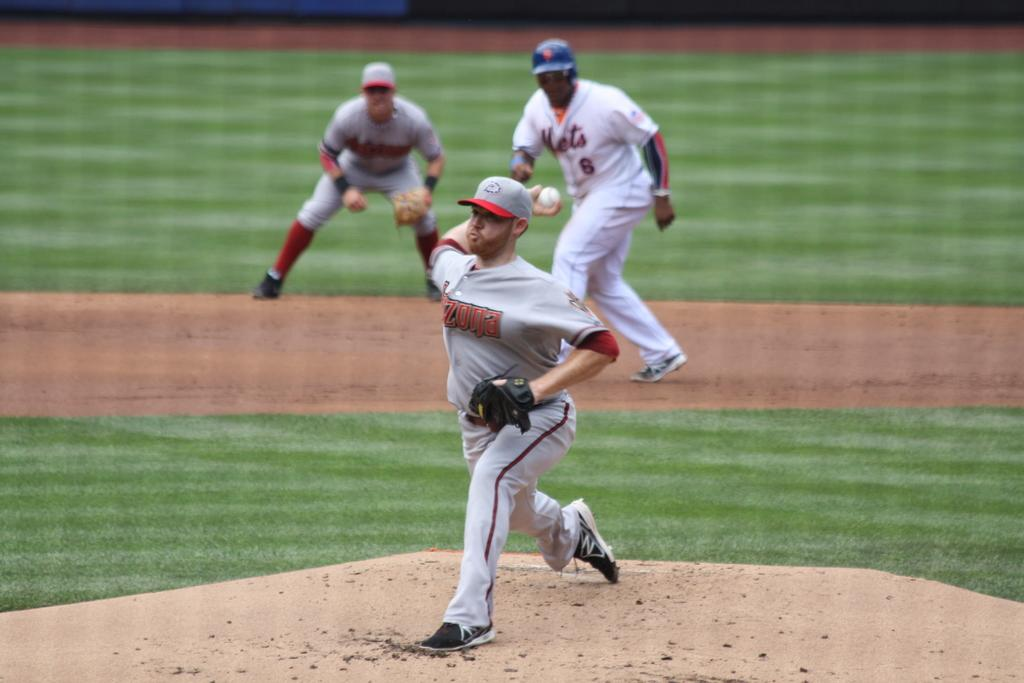<image>
Provide a brief description of the given image. A player wearing a Mets jersey with number 6 starts to run behind the pitcher. 